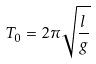Convert formula to latex. <formula><loc_0><loc_0><loc_500><loc_500>T _ { 0 } = 2 \pi \sqrt { \frac { l } { g } }</formula> 